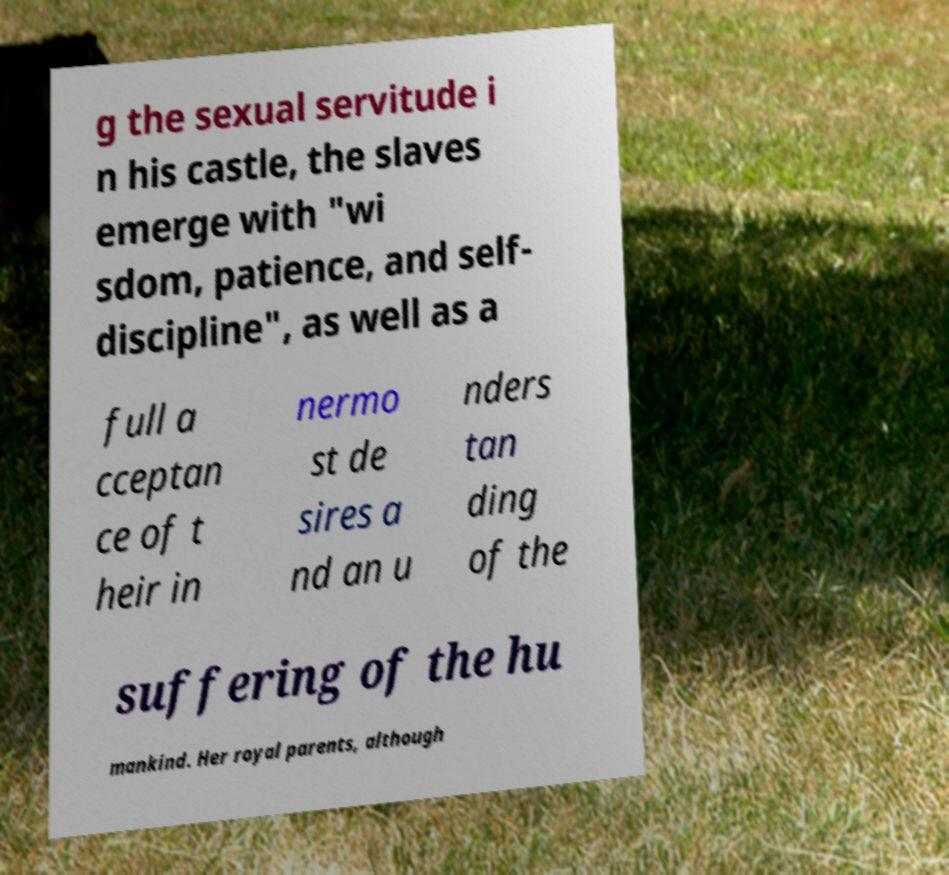Please identify and transcribe the text found in this image. g the sexual servitude i n his castle, the slaves emerge with "wi sdom, patience, and self- discipline", as well as a full a cceptan ce of t heir in nermo st de sires a nd an u nders tan ding of the suffering of the hu mankind. Her royal parents, although 